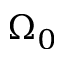Convert formula to latex. <formula><loc_0><loc_0><loc_500><loc_500>\Omega _ { 0 }</formula> 